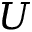Convert formula to latex. <formula><loc_0><loc_0><loc_500><loc_500>U</formula> 